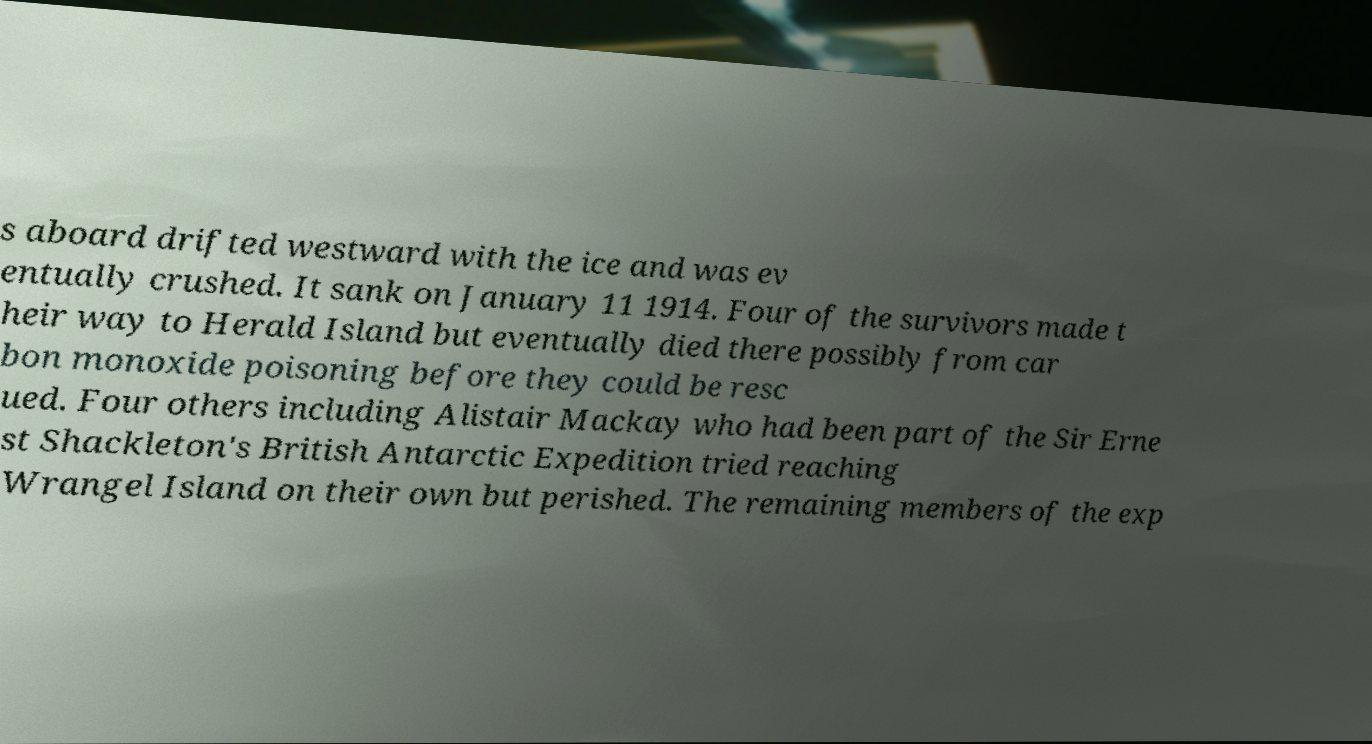What messages or text are displayed in this image? I need them in a readable, typed format. s aboard drifted westward with the ice and was ev entually crushed. It sank on January 11 1914. Four of the survivors made t heir way to Herald Island but eventually died there possibly from car bon monoxide poisoning before they could be resc ued. Four others including Alistair Mackay who had been part of the Sir Erne st Shackleton's British Antarctic Expedition tried reaching Wrangel Island on their own but perished. The remaining members of the exp 